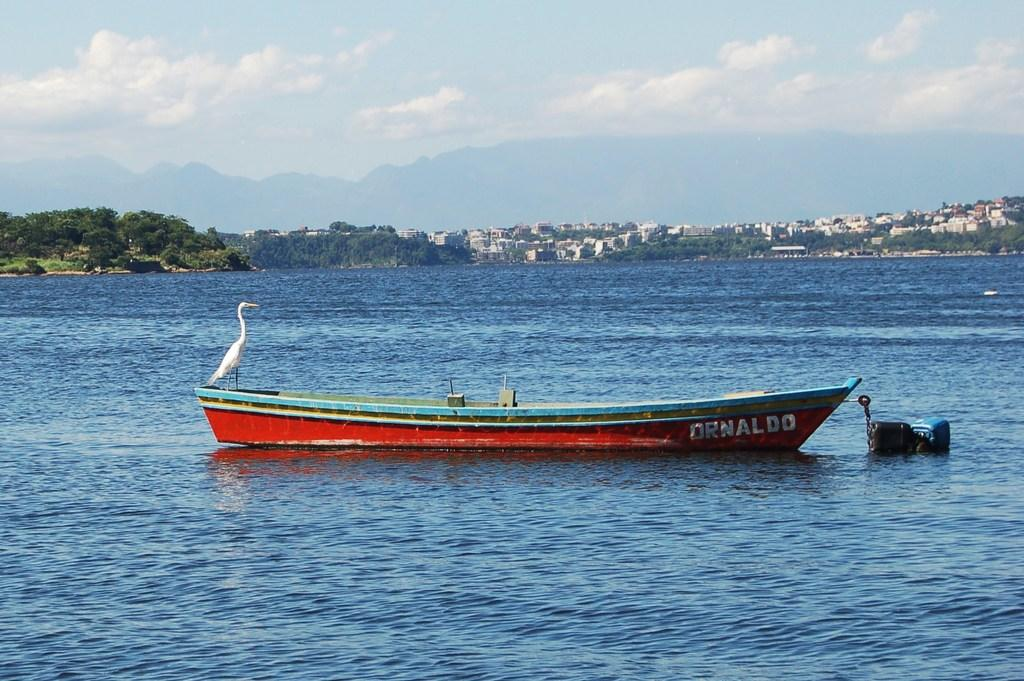What is the main subject in the center of the image? There is a boat in the center of the image. Where is the boat located? The boat is on a river. What animal can be seen on the boat? There is a swan on the boat. What can be seen in the background of the image? There are trees, buildings, hills, and the sky visible in the background of the image. What is the condition of the sky in the image? The sky is visible in the background of the image, and there are clouds present. What type of harmony is being played by the swan on the boat? There is no indication in the image that the swan is playing any type of harmony, as swans do not have the ability to play musical instruments. 